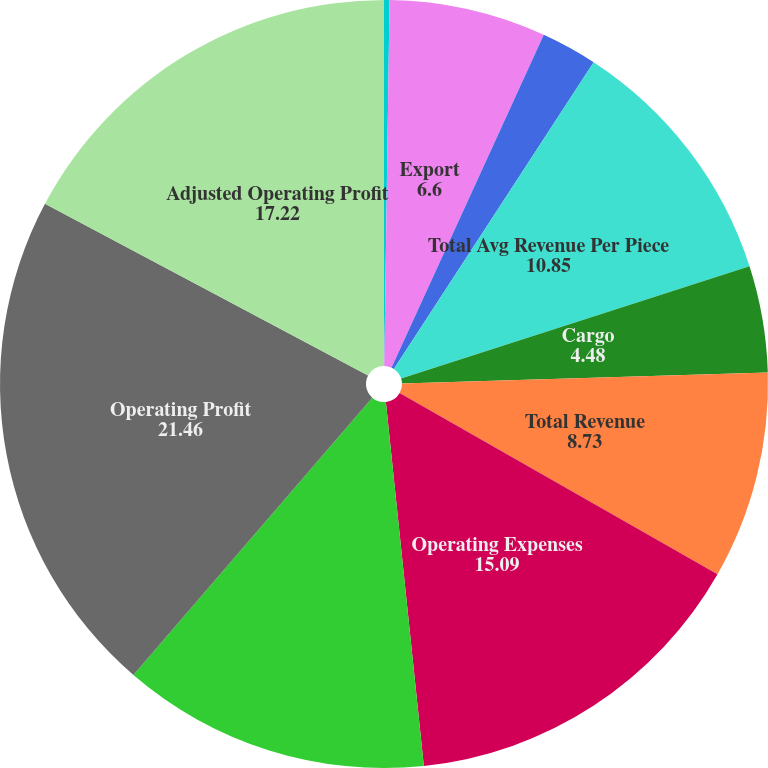Convert chart to OTSL. <chart><loc_0><loc_0><loc_500><loc_500><pie_chart><fcel>Domestic<fcel>Export<fcel>Total Avg Daily Package Volume<fcel>Total Avg Revenue Per Piece<fcel>Cargo<fcel>Total Revenue<fcel>Operating Expenses<fcel>Adjusted Operating Expenses<fcel>Operating Profit<fcel>Adjusted Operating Profit<nl><fcel>0.23%<fcel>6.6%<fcel>2.36%<fcel>10.85%<fcel>4.48%<fcel>8.73%<fcel>15.09%<fcel>12.97%<fcel>21.46%<fcel>17.22%<nl></chart> 